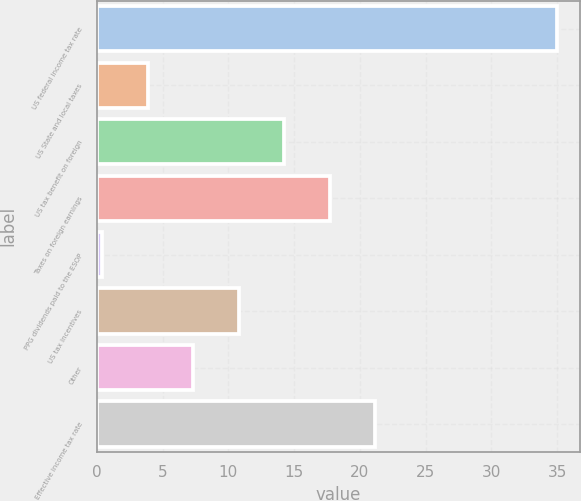<chart> <loc_0><loc_0><loc_500><loc_500><bar_chart><fcel>US federal income tax rate<fcel>US State and local taxes<fcel>US tax benefit on foreign<fcel>Taxes on foreign earnings<fcel>PPG dividends paid to the ESOP<fcel>US tax incentives<fcel>Other<fcel>Effective income tax rate<nl><fcel>35<fcel>3.86<fcel>14.24<fcel>17.7<fcel>0.4<fcel>10.78<fcel>7.32<fcel>21.16<nl></chart> 